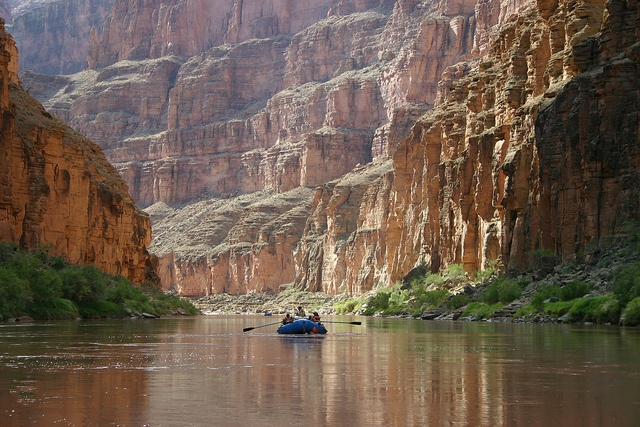Describe the objects in this image and their specific colors. I can see boat in gray, black, navy, blue, and maroon tones, people in gray, black, maroon, and darkgray tones, people in gray, black, and maroon tones, and people in gray, black, and maroon tones in this image. 